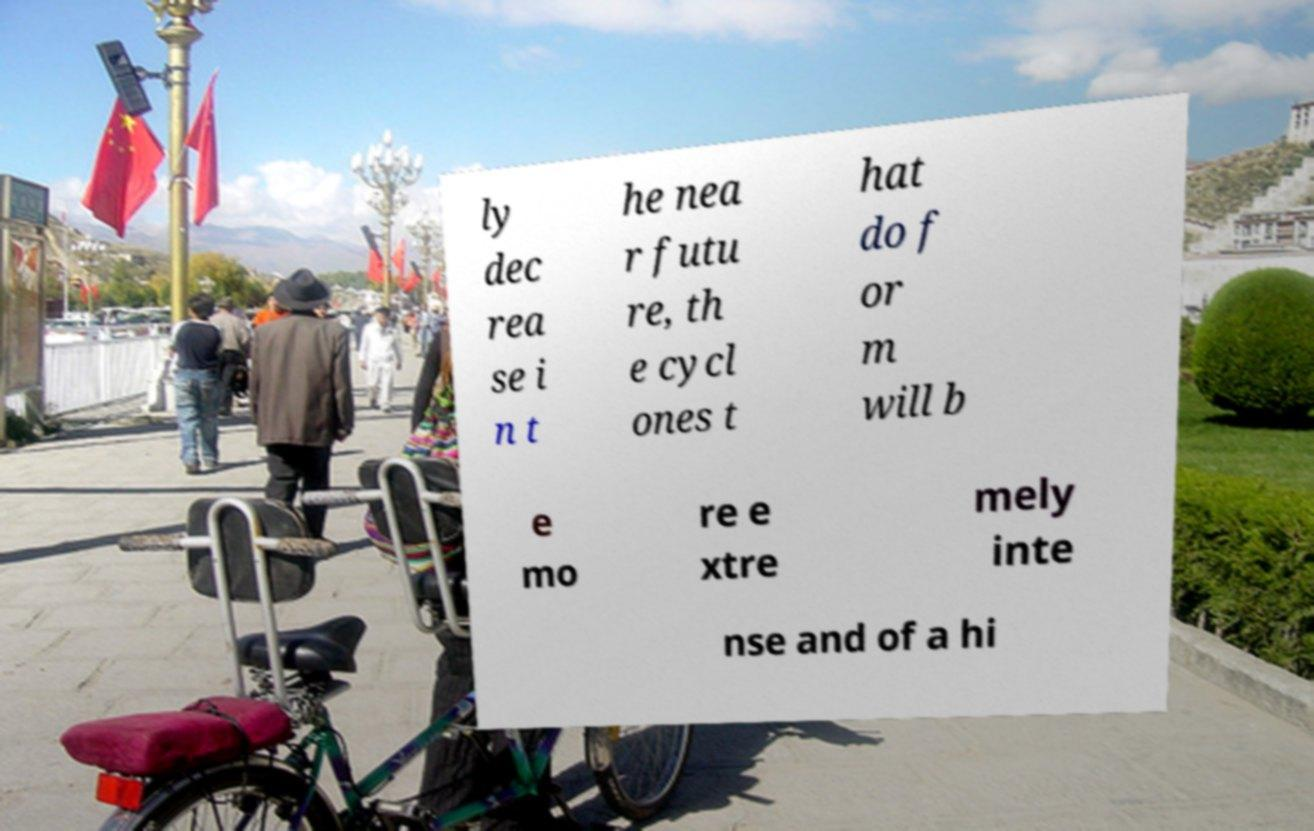For documentation purposes, I need the text within this image transcribed. Could you provide that? ly dec rea se i n t he nea r futu re, th e cycl ones t hat do f or m will b e mo re e xtre mely inte nse and of a hi 